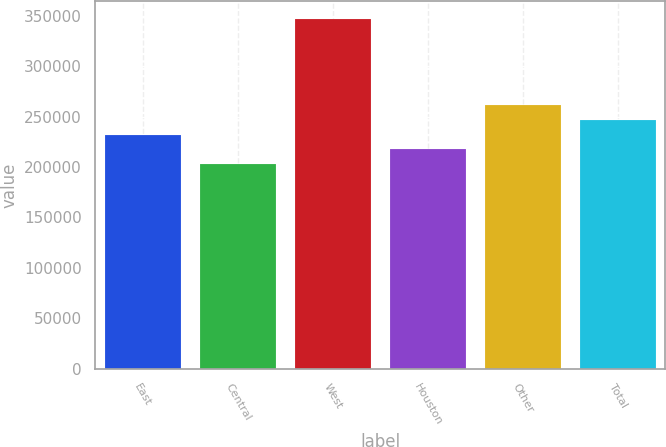Convert chart. <chart><loc_0><loc_0><loc_500><loc_500><bar_chart><fcel>East<fcel>Central<fcel>West<fcel>Houston<fcel>Other<fcel>Total<nl><fcel>231800<fcel>203000<fcel>347000<fcel>217400<fcel>261400<fcel>247000<nl></chart> 